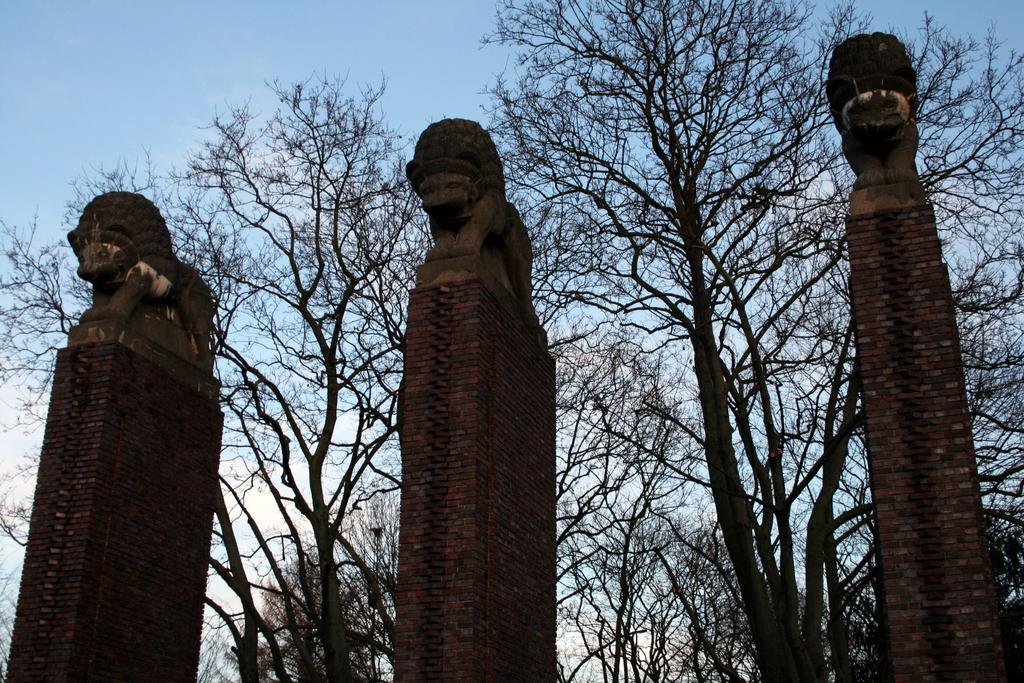What can be found in the center of the image? There are three pillars and three sculptures in the center of the image. What is visible in the background of the image? There are trees in the background of the image. What is visible at the top of the image? The sky is visible at the top of the image. What type of meal is being served in the image? There is no meal present in the image; it features three pillars, three sculptures, trees in the background, and the sky at the top. Can you see a locket hanging from one of the sculptures in the image? There is no locket visible on any of the sculptures in the image. 